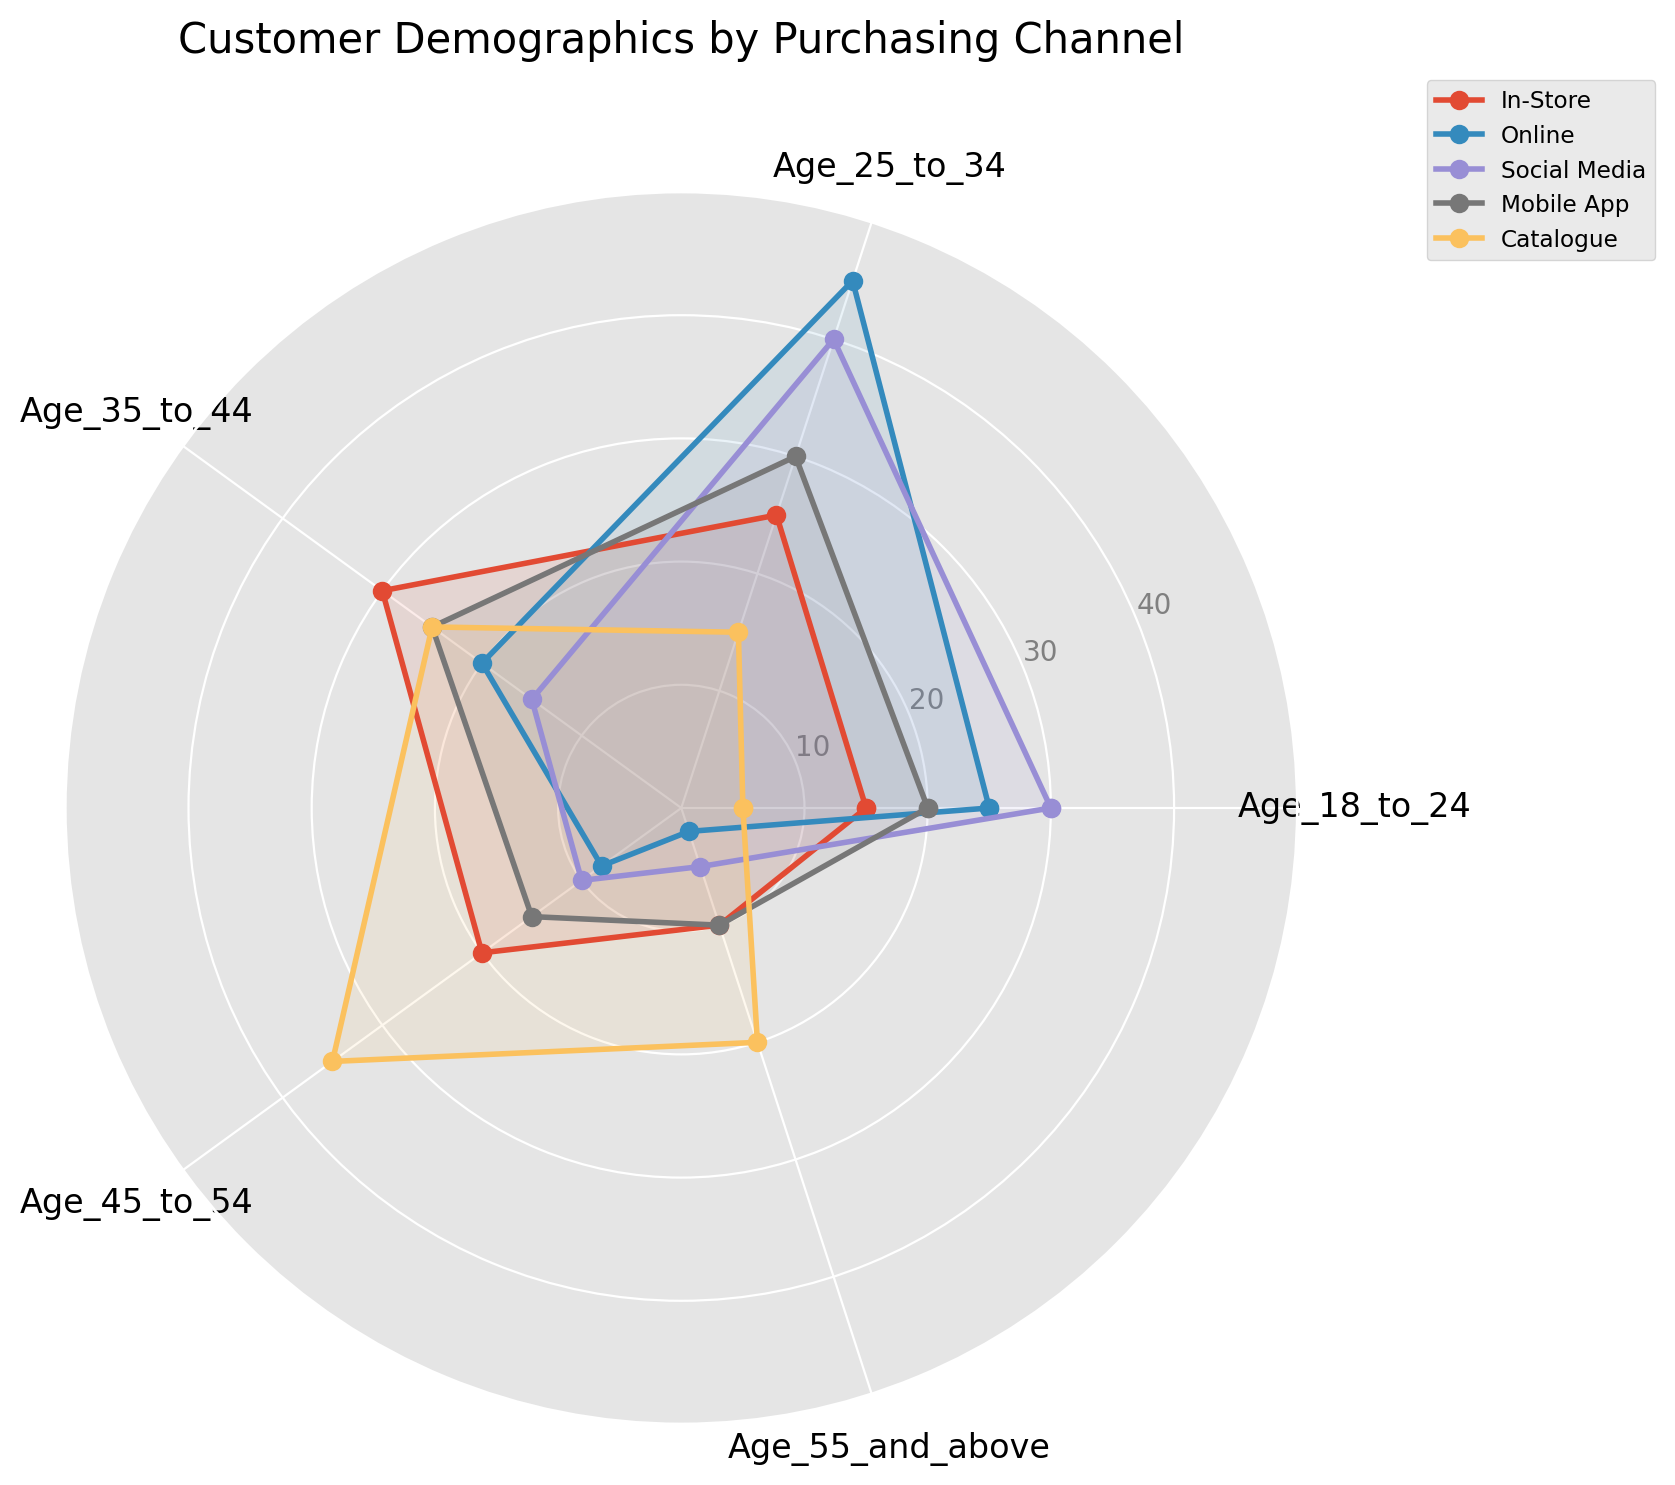Which channel has the highest percentage of customers aged 18 to 24? The radar chart shows the values for each channel and age group. The highest value for the 18 to 24 age group is 30, which corresponds to the Social Media channel.
Answer: Social Media Which channel has the lowest percentage of customers aged 55 and above? The radar chart shows the values for each channel and age group. The lowest value for the 55 and above age group is 2, which corresponds to the Online channel.
Answer: Online How many more customers aged 25 to 34 shop online compared to in-store? The radar chart shows 25 customers aged 25 to 34 for In-Store versus 45 for Online. The difference is 45 - 25 = 20 more customers shop online.
Answer: 20 What is the average number of customers aged 35 to 44 across all channels? Sum the values for each channel in the 35 to 44 age group: 30 (In-Store) + 20 (Online) + 15 (Social Media) + 25 (Mobile App) + 25 (Catalogue) = 115. There are 5 channels, so the average is 115 / 5 = 23.
Answer: 23 Compare the number of customers aged 45 to 54 who shop through the Catalogue with the number of customers aged 45 to 54 who shop through the Mobile App. Which one is greater, and by how much? The radar chart shows 35 customers aged 45 to 54 for Catalogue versus 15 for Mobile App. Catalogue has 35 - 15 = 20 more customers in this age group than Mobile App.
Answer: Catalogue, 20 more What is the total number of customers aged 18 to 24 across all channels? Sum the values for the 18 to 24 age group across all channels: 15 (In-Store) + 25 (Online) + 30 (Social Media) + 20 (Mobile App) + 5 (Catalogue) = 95.
Answer: 95 Which age group has the most similar number of customers across all channels, and what is the respective standard deviation? By visually inspecting the radar chart, the age group 35 to 44 seems to have the most balanced numbers across channels. Calculating the standard deviation for 35 to 44 (values are 30, 20, 15, 25, 25): mean is 23, standard deviation is around 5.96.
Answer: 35 to 44, std ≈ 5.96 Which purchasing channel has the widest range of customer ages represented? The range of customer ages for each channel is visually evident by the span between the highest and lowest values. Social Media and Catalogue both have wide age ranges, but checking values: Social Media (30 to 5), Catalogue (35 to 5), Catalogue has a range of 30 which is wider.
Answer: Catalogue How does the percentage of customers aged 55 and above who use the Catalogue compare to those who shop In-Store? From the radar chart, the number of elderly customers is 20 for the Catalogue and 10 for In-Store, making Catalogue's number twice that of In-Store.
Answer: Catalogue, twice Which purchasing channel has the most balanced customer distribution across all age groups, and how can this be visually determined? Visually inspecting the radar chart, the Mobile App channel appears most balanced as its plotted values for each age group are more evenly spread compared to other channels.
Answer: Mobile App 